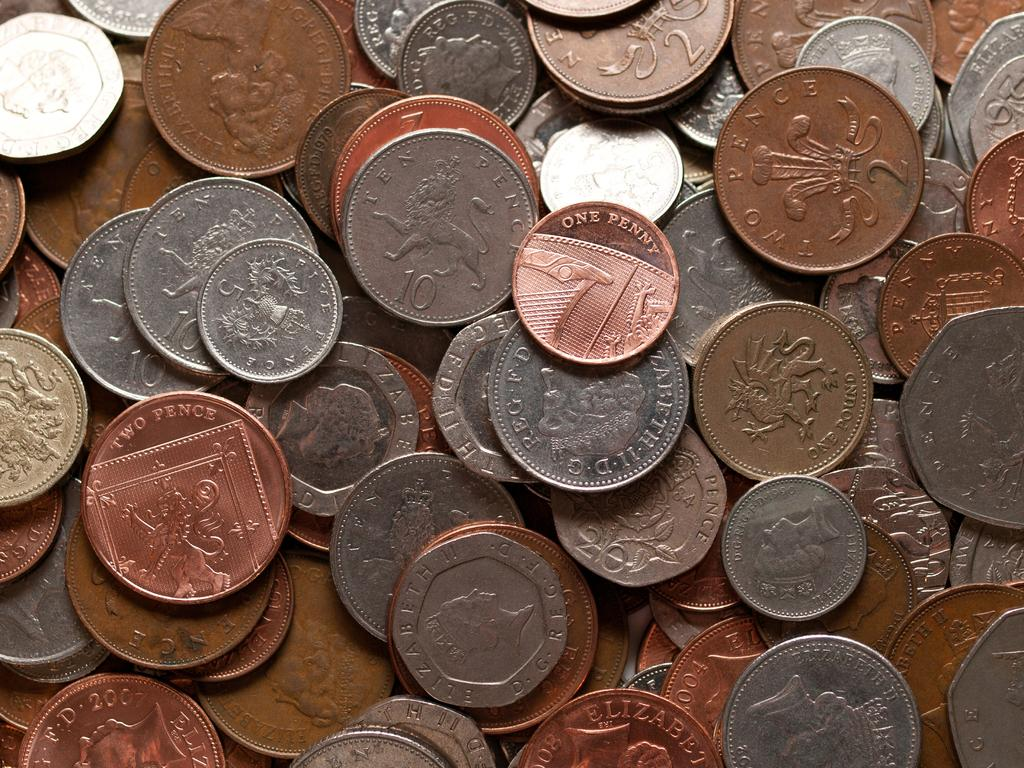What objects are present in the image? There are coins in the image. How can the coins be distinguished from one another? The coins have different colors. What information is present on the coins? The coins have text and images on them. What type of work does the mind perform in the image? There is no mind or work present in the image; it only features coins with different colors, text, and images. 